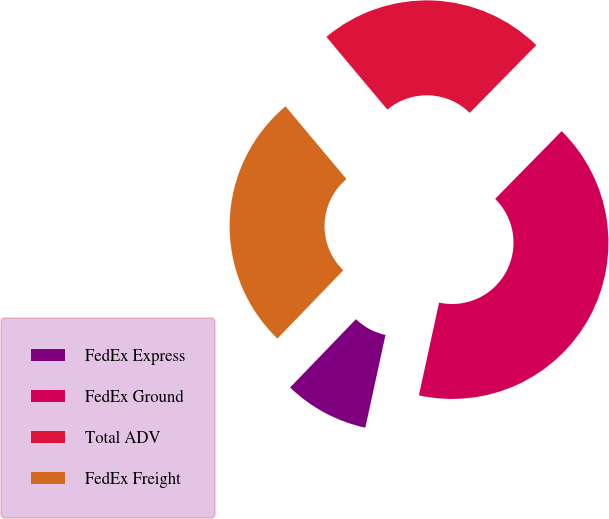<chart> <loc_0><loc_0><loc_500><loc_500><pie_chart><fcel>FedEx Express<fcel>FedEx Ground<fcel>Total ADV<fcel>FedEx Freight<nl><fcel>8.8%<fcel>41.06%<fcel>23.46%<fcel>26.69%<nl></chart> 